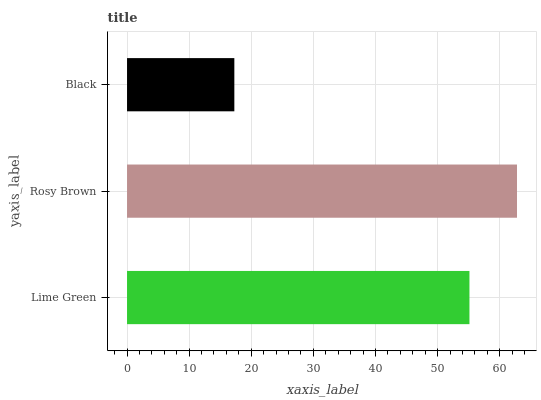Is Black the minimum?
Answer yes or no. Yes. Is Rosy Brown the maximum?
Answer yes or no. Yes. Is Rosy Brown the minimum?
Answer yes or no. No. Is Black the maximum?
Answer yes or no. No. Is Rosy Brown greater than Black?
Answer yes or no. Yes. Is Black less than Rosy Brown?
Answer yes or no. Yes. Is Black greater than Rosy Brown?
Answer yes or no. No. Is Rosy Brown less than Black?
Answer yes or no. No. Is Lime Green the high median?
Answer yes or no. Yes. Is Lime Green the low median?
Answer yes or no. Yes. Is Rosy Brown the high median?
Answer yes or no. No. Is Black the low median?
Answer yes or no. No. 